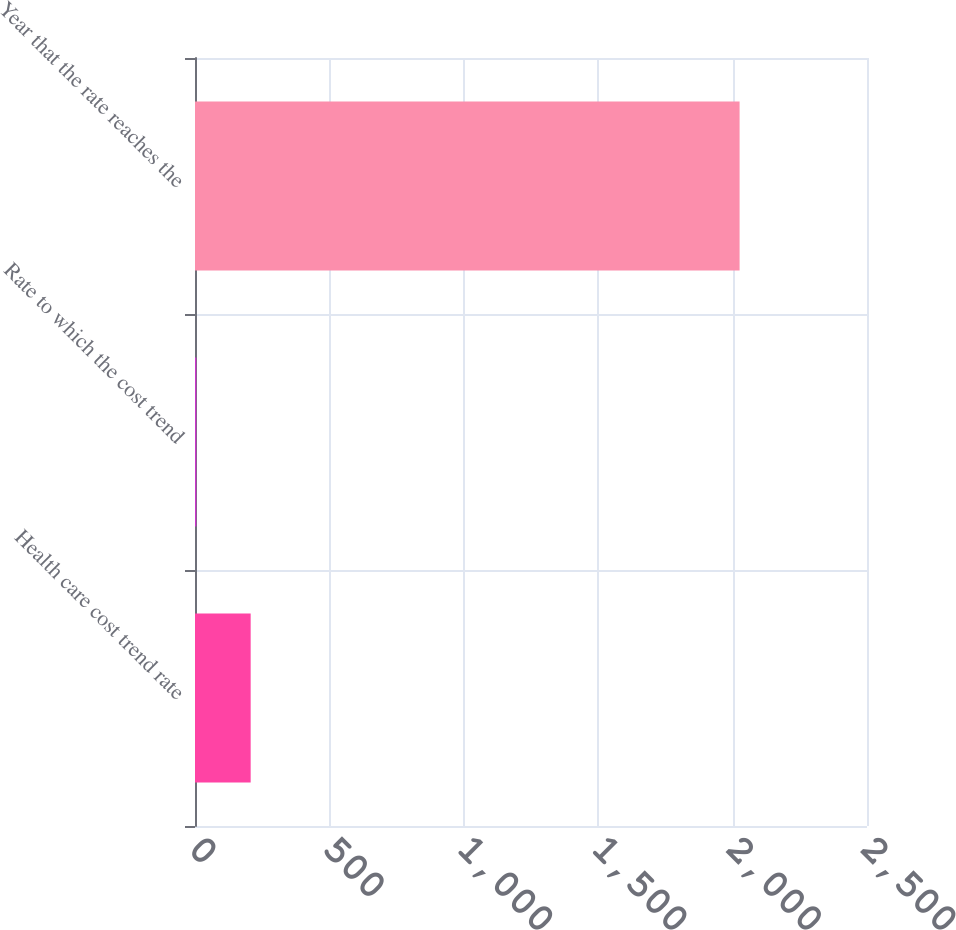Convert chart to OTSL. <chart><loc_0><loc_0><loc_500><loc_500><bar_chart><fcel>Health care cost trend rate<fcel>Rate to which the cost trend<fcel>Year that the rate reaches the<nl><fcel>207.1<fcel>5<fcel>2026<nl></chart> 